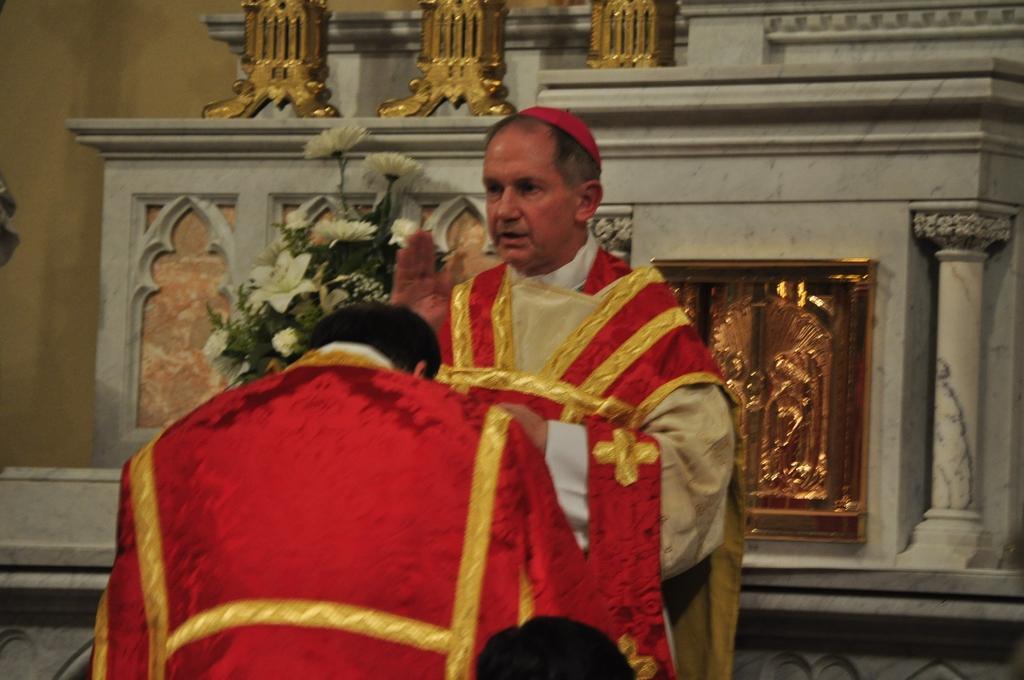How would you summarize this image in a sentence or two? In the image there is a priest in red dress standing in the front with a person in front of him and behind him there is wall with a flower bouquet on the shelf. 